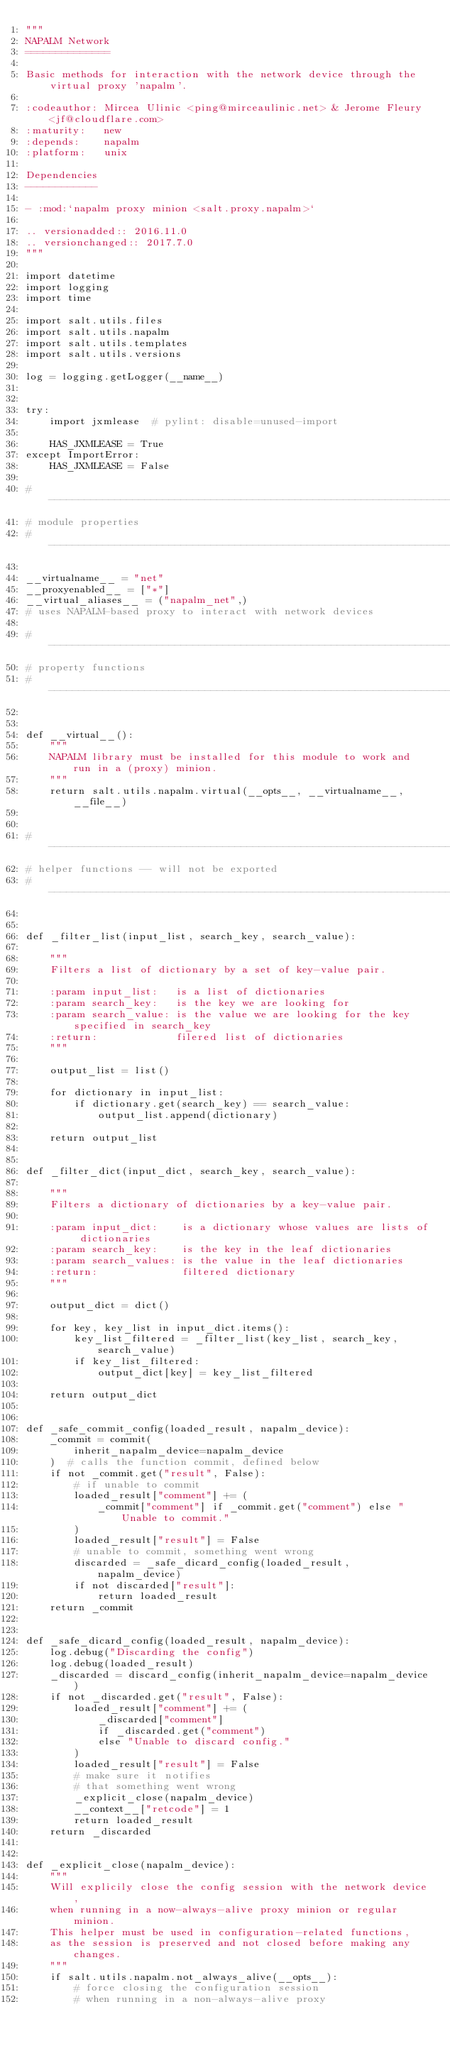<code> <loc_0><loc_0><loc_500><loc_500><_Python_>"""
NAPALM Network
==============

Basic methods for interaction with the network device through the virtual proxy 'napalm'.

:codeauthor: Mircea Ulinic <ping@mirceaulinic.net> & Jerome Fleury <jf@cloudflare.com>
:maturity:   new
:depends:    napalm
:platform:   unix

Dependencies
------------

- :mod:`napalm proxy minion <salt.proxy.napalm>`

.. versionadded:: 2016.11.0
.. versionchanged:: 2017.7.0
"""

import datetime
import logging
import time

import salt.utils.files
import salt.utils.napalm
import salt.utils.templates
import salt.utils.versions

log = logging.getLogger(__name__)


try:
    import jxmlease  # pylint: disable=unused-import

    HAS_JXMLEASE = True
except ImportError:
    HAS_JXMLEASE = False

# ----------------------------------------------------------------------------------------------------------------------
# module properties
# ----------------------------------------------------------------------------------------------------------------------

__virtualname__ = "net"
__proxyenabled__ = ["*"]
__virtual_aliases__ = ("napalm_net",)
# uses NAPALM-based proxy to interact with network devices

# ----------------------------------------------------------------------------------------------------------------------
# property functions
# ----------------------------------------------------------------------------------------------------------------------


def __virtual__():
    """
    NAPALM library must be installed for this module to work and run in a (proxy) minion.
    """
    return salt.utils.napalm.virtual(__opts__, __virtualname__, __file__)


# ----------------------------------------------------------------------------------------------------------------------
# helper functions -- will not be exported
# ----------------------------------------------------------------------------------------------------------------------


def _filter_list(input_list, search_key, search_value):

    """
    Filters a list of dictionary by a set of key-value pair.

    :param input_list:   is a list of dictionaries
    :param search_key:   is the key we are looking for
    :param search_value: is the value we are looking for the key specified in search_key
    :return:             filered list of dictionaries
    """

    output_list = list()

    for dictionary in input_list:
        if dictionary.get(search_key) == search_value:
            output_list.append(dictionary)

    return output_list


def _filter_dict(input_dict, search_key, search_value):

    """
    Filters a dictionary of dictionaries by a key-value pair.

    :param input_dict:    is a dictionary whose values are lists of dictionaries
    :param search_key:    is the key in the leaf dictionaries
    :param search_values: is the value in the leaf dictionaries
    :return:              filtered dictionary
    """

    output_dict = dict()

    for key, key_list in input_dict.items():
        key_list_filtered = _filter_list(key_list, search_key, search_value)
        if key_list_filtered:
            output_dict[key] = key_list_filtered

    return output_dict


def _safe_commit_config(loaded_result, napalm_device):
    _commit = commit(
        inherit_napalm_device=napalm_device
    )  # calls the function commit, defined below
    if not _commit.get("result", False):
        # if unable to commit
        loaded_result["comment"] += (
            _commit["comment"] if _commit.get("comment") else "Unable to commit."
        )
        loaded_result["result"] = False
        # unable to commit, something went wrong
        discarded = _safe_dicard_config(loaded_result, napalm_device)
        if not discarded["result"]:
            return loaded_result
    return _commit


def _safe_dicard_config(loaded_result, napalm_device):
    log.debug("Discarding the config")
    log.debug(loaded_result)
    _discarded = discard_config(inherit_napalm_device=napalm_device)
    if not _discarded.get("result", False):
        loaded_result["comment"] += (
            _discarded["comment"]
            if _discarded.get("comment")
            else "Unable to discard config."
        )
        loaded_result["result"] = False
        # make sure it notifies
        # that something went wrong
        _explicit_close(napalm_device)
        __context__["retcode"] = 1
        return loaded_result
    return _discarded


def _explicit_close(napalm_device):
    """
    Will explicily close the config session with the network device,
    when running in a now-always-alive proxy minion or regular minion.
    This helper must be used in configuration-related functions,
    as the session is preserved and not closed before making any changes.
    """
    if salt.utils.napalm.not_always_alive(__opts__):
        # force closing the configuration session
        # when running in a non-always-alive proxy</code> 